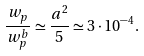Convert formula to latex. <formula><loc_0><loc_0><loc_500><loc_500>\frac { w _ { p } } { w _ { p } ^ { b } } \simeq \frac { a ^ { 2 } } { 5 } \simeq 3 \cdot 1 0 ^ { - 4 } .</formula> 